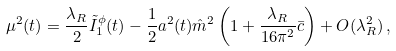<formula> <loc_0><loc_0><loc_500><loc_500>\mu ^ { 2 } ( t ) = \frac { \lambda _ { R } } { 2 } \tilde { I } _ { 1 } ^ { \phi } ( t ) - \frac { 1 } { 2 } a ^ { 2 } ( t ) \hat { m } ^ { 2 } \left ( 1 + \frac { \lambda _ { R } } { 1 6 \pi ^ { 2 } } \bar { c } \right ) + O ( \lambda _ { R } ^ { 2 } ) \, ,</formula> 